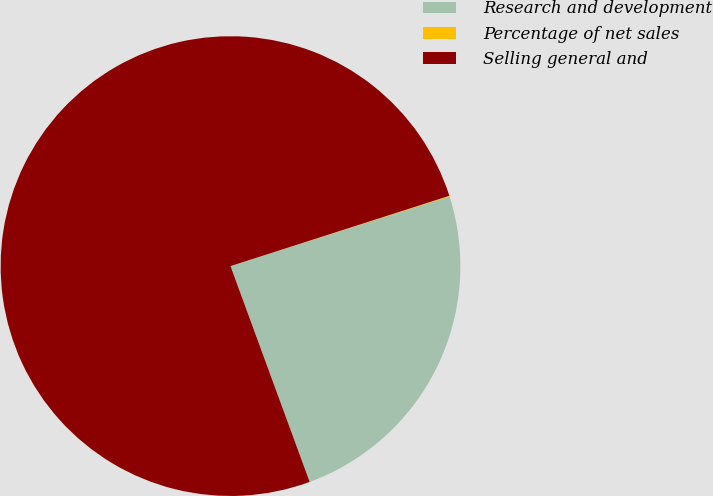<chart> <loc_0><loc_0><loc_500><loc_500><pie_chart><fcel>Research and development<fcel>Percentage of net sales<fcel>Selling general and<nl><fcel>24.3%<fcel>0.05%<fcel>75.64%<nl></chart> 